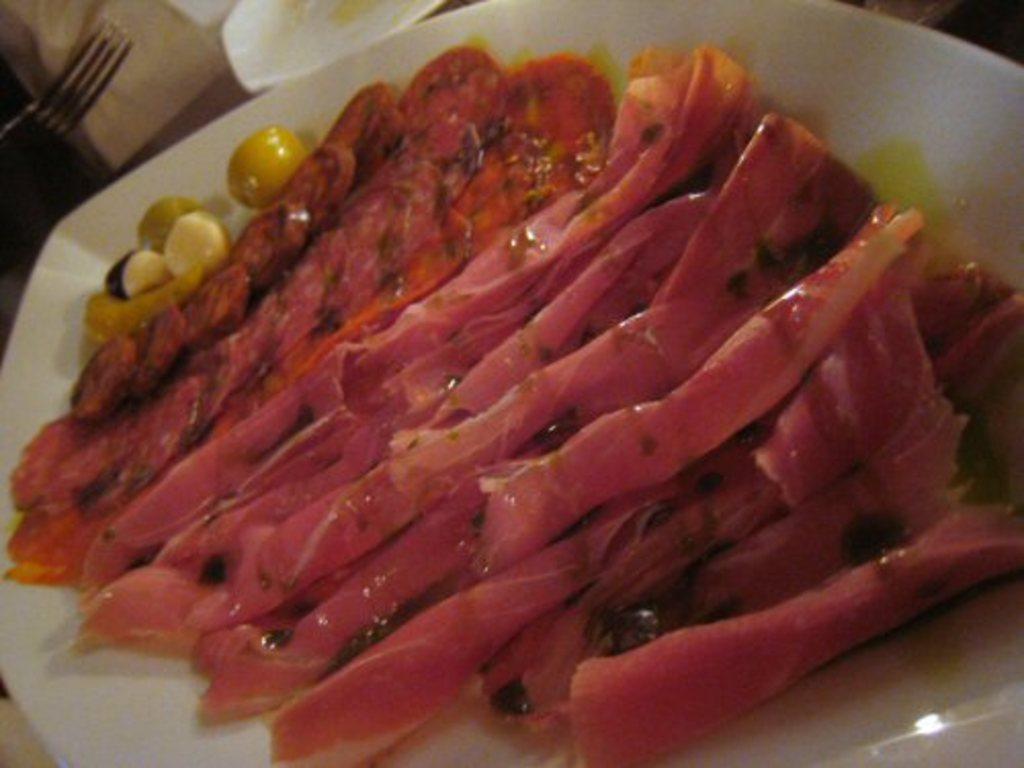Please provide a concise description of this image. In this image there is a plate. In the plate there is some food stuff. On the left side there is a fork beside the plate. 